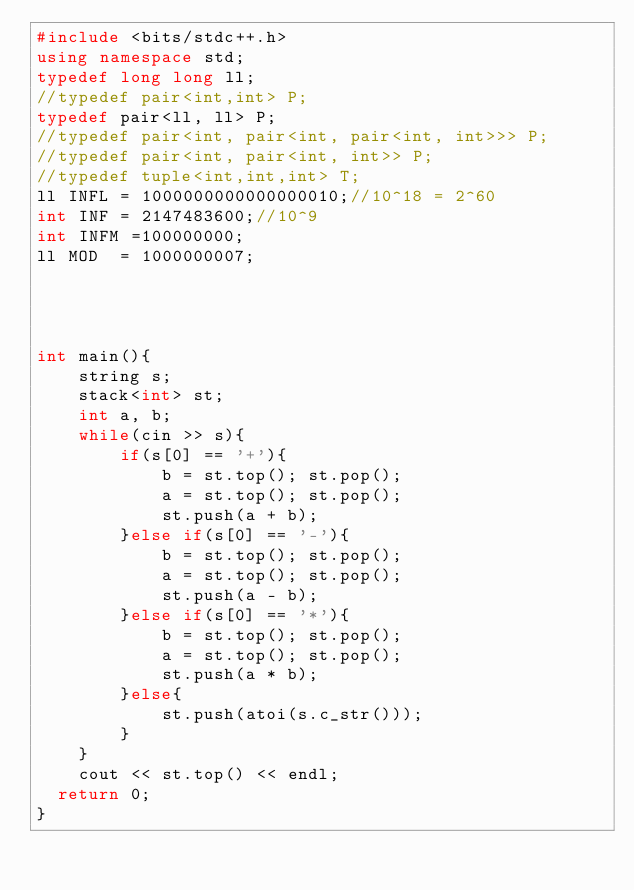<code> <loc_0><loc_0><loc_500><loc_500><_C++_>#include <bits/stdc++.h> 
using namespace std;
typedef long long ll;
//typedef pair<int,int> P;
typedef pair<ll, ll> P;
//typedef pair<int, pair<int, pair<int, int>>> P;
//typedef pair<int, pair<int, int>> P;
//typedef tuple<int,int,int> T;
ll INFL = 1000000000000000010;//10^18 = 2^60
int INF = 2147483600;//10^9
int INFM =100000000;
ll MOD  = 1000000007;
 

 
 
int main(){
    string s;
    stack<int> st;
    int a, b;
    while(cin >> s){
        if(s[0] == '+'){
            b = st.top(); st.pop();
            a = st.top(); st.pop();
            st.push(a + b);
        }else if(s[0] == '-'){
            b = st.top(); st.pop();
            a = st.top(); st.pop();
            st.push(a - b);
        }else if(s[0] == '*'){
            b = st.top(); st.pop();
            a = st.top(); st.pop();
            st.push(a * b);        
        }else{
            st.push(atoi(s.c_str()));
        }
    }
    cout << st.top() << endl;
  return 0;
}
</code> 